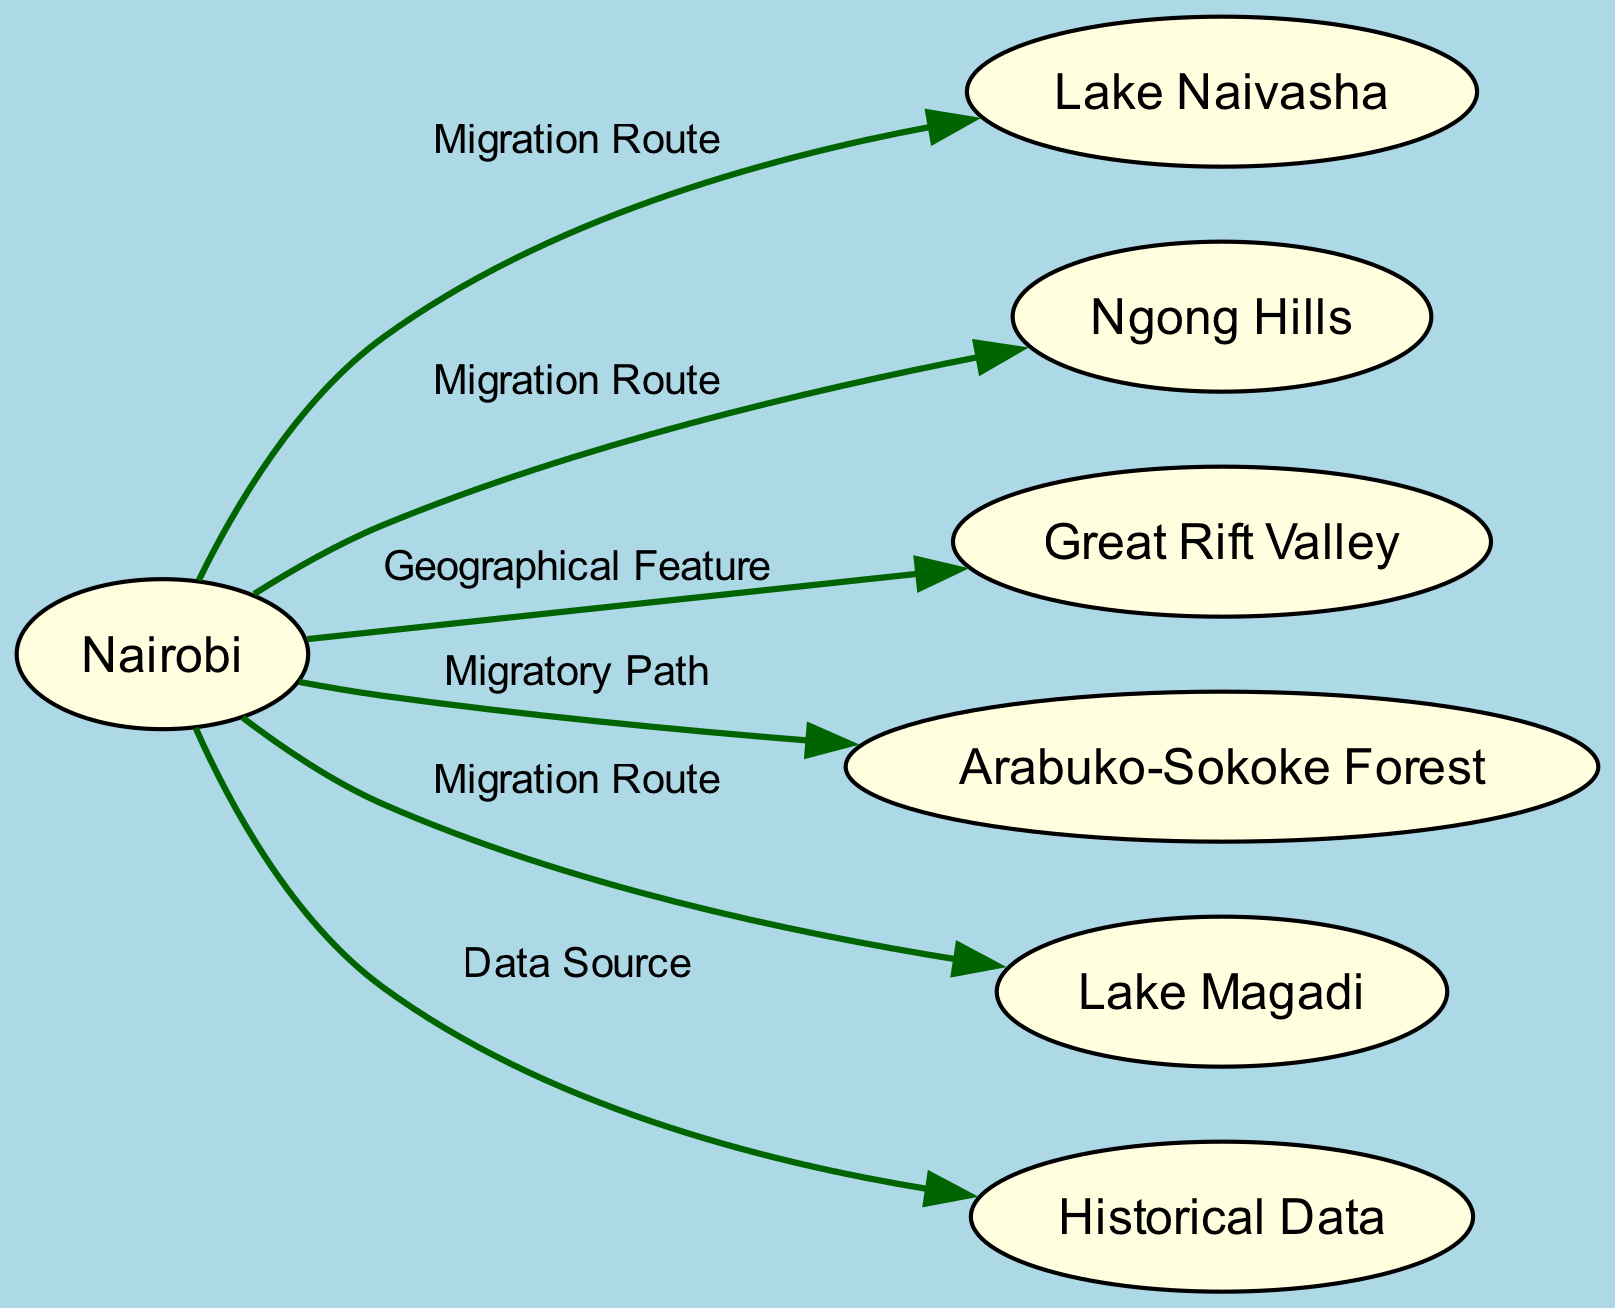What are the main locations mentioned in the diagram? The diagram includes several locations as nodes: Nairobi, Lake Naivasha, Ngong Hills, Great Rift Valley, Arabuko-Sokoke Forest, and Lake Magadi. These locations are specifically identified as key points in the migration patterns of birds.
Answer: Nairobi, Lake Naivasha, Ngong Hills, Great Rift Valley, Arabuko-Sokoke Forest, Lake Magadi How many nodes are present in the diagram? The diagram lists a total of 7 nodes. Each node corresponds to a key location in the bird migration patterns, and they are all clearly defined in the data provided.
Answer: 7 What route do birds take from Nairobi to Lake Naivasha? The diagram indicates a direct migration route that leads from Nairobi to Lake Naivasha, emphasizing that this is a path taken by birds during their migration.
Answer: Migration Route What is the significance of the Great Rift Valley in the diagram? The Great Rift Valley is labeled as a geographical feature in the diagram, which serves as a natural pathway for migratory birds, facilitating their movement between different ecosystems.
Answer: Natural pathway Which birds are specifically mentioned to travel to Lake Magadi? The diagram explicitly notes that flamingos and other waterbirds are the species that travel to Lake Magadi, highlighting its importance as a site for these birds.
Answer: Flamingos and other waterbirds What historical data has been collected about bird migration? Historical data that has been collected since the early 20th century is noted in the diagram as a source of information used to track changes in bird migration patterns over time.
Answer: Early 20th century Which species is associated with the Arabuko-Sokoke Forest? The diagram mentions the globally threatened Sokoke scops owl as a species that is associated with the Arabuko-Sokoke Forest, underlining the ecological significance of this area for wildlife.
Answer: Sokoke scops owl What seasonal patterns are observed in the Ngong Hills? The diagram specifies that raptors are particularly seen during migration seasons in Ngong Hills, especially in the month of October, indicating a seasonal aspect to the bird migration observed there.
Answer: October 